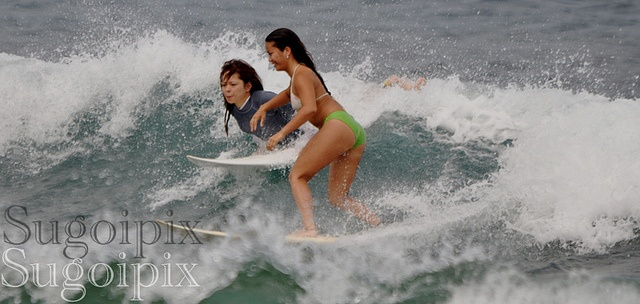Describe the objects in this image and their specific colors. I can see people in gray, brown, maroon, and black tones, people in gray, black, and maroon tones, surfboard in gray, darkgray, and lightgray tones, and surfboard in gray, darkgray, and tan tones in this image. 